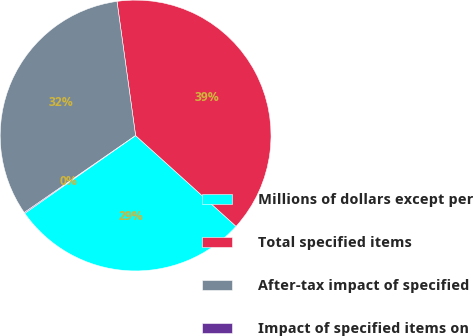Convert chart to OTSL. <chart><loc_0><loc_0><loc_500><loc_500><pie_chart><fcel>Millions of dollars except per<fcel>Total specified items<fcel>After-tax impact of specified<fcel>Impact of specified items on<nl><fcel>28.56%<fcel>38.89%<fcel>32.44%<fcel>0.11%<nl></chart> 